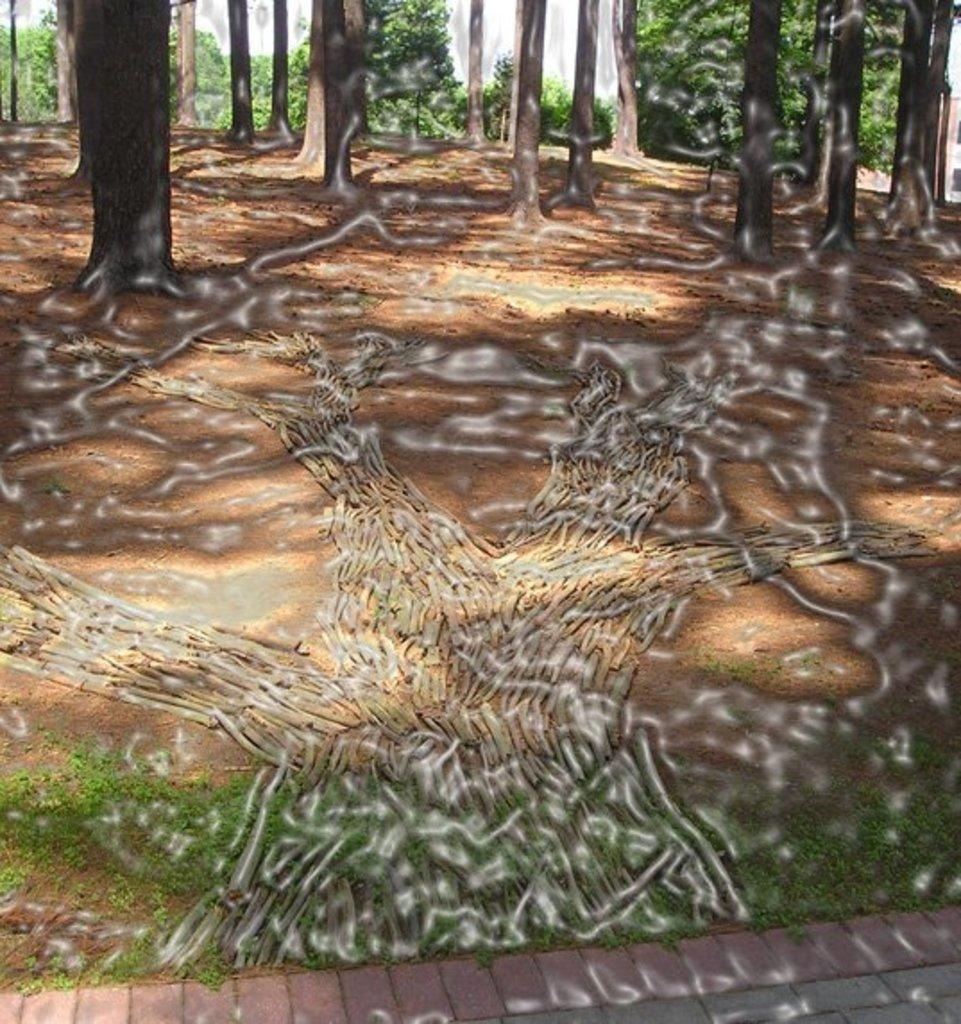Please provide a concise description of this image. In this picture we can see trees. This is grass and there are roots. 